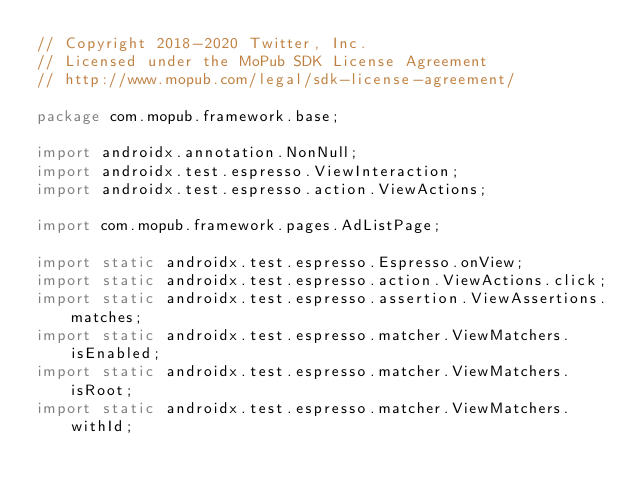<code> <loc_0><loc_0><loc_500><loc_500><_Java_>// Copyright 2018-2020 Twitter, Inc.
// Licensed under the MoPub SDK License Agreement
// http://www.mopub.com/legal/sdk-license-agreement/

package com.mopub.framework.base;

import androidx.annotation.NonNull;
import androidx.test.espresso.ViewInteraction;
import androidx.test.espresso.action.ViewActions;

import com.mopub.framework.pages.AdListPage;

import static androidx.test.espresso.Espresso.onView;
import static androidx.test.espresso.action.ViewActions.click;
import static androidx.test.espresso.assertion.ViewAssertions.matches;
import static androidx.test.espresso.matcher.ViewMatchers.isEnabled;
import static androidx.test.espresso.matcher.ViewMatchers.isRoot;
import static androidx.test.espresso.matcher.ViewMatchers.withId;</code> 